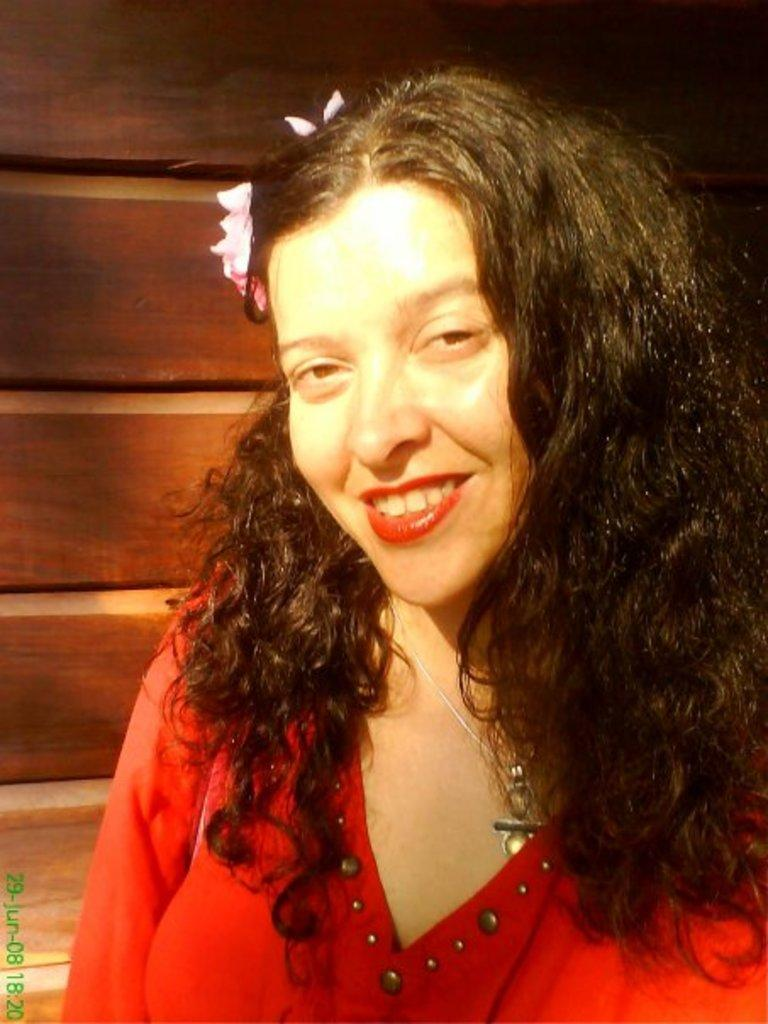Who is the main subject in the image? There is a woman in the image. Where is the woman located in the image? The woman is on the right side of the image. What is the woman wearing? The woman is wearing a red dress. What can be seen in the background of the image? There is a wooden wall in the background of the image. What type of treatment is the woman receiving in the image? There is no indication in the image that the woman is receiving any treatment. 